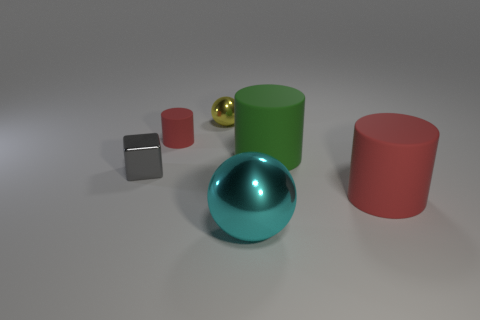Add 3 large brown rubber cubes. How many objects exist? 9 Subtract all blocks. How many objects are left? 5 Add 1 rubber objects. How many rubber objects are left? 4 Add 6 green cylinders. How many green cylinders exist? 7 Subtract 1 gray blocks. How many objects are left? 5 Subtract all tiny red metal things. Subtract all red cylinders. How many objects are left? 4 